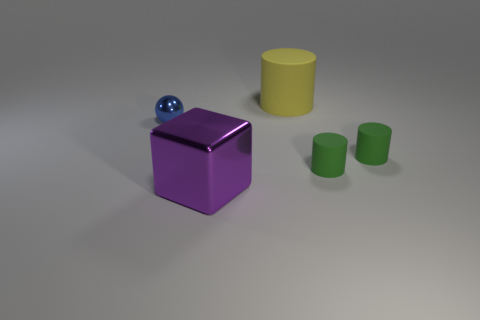Add 5 blue metal things. How many objects exist? 10 Subtract all spheres. How many objects are left? 4 Add 4 big blue cubes. How many big blue cubes exist? 4 Subtract 2 green cylinders. How many objects are left? 3 Subtract all green things. Subtract all small blue metallic balls. How many objects are left? 2 Add 2 small matte objects. How many small matte objects are left? 4 